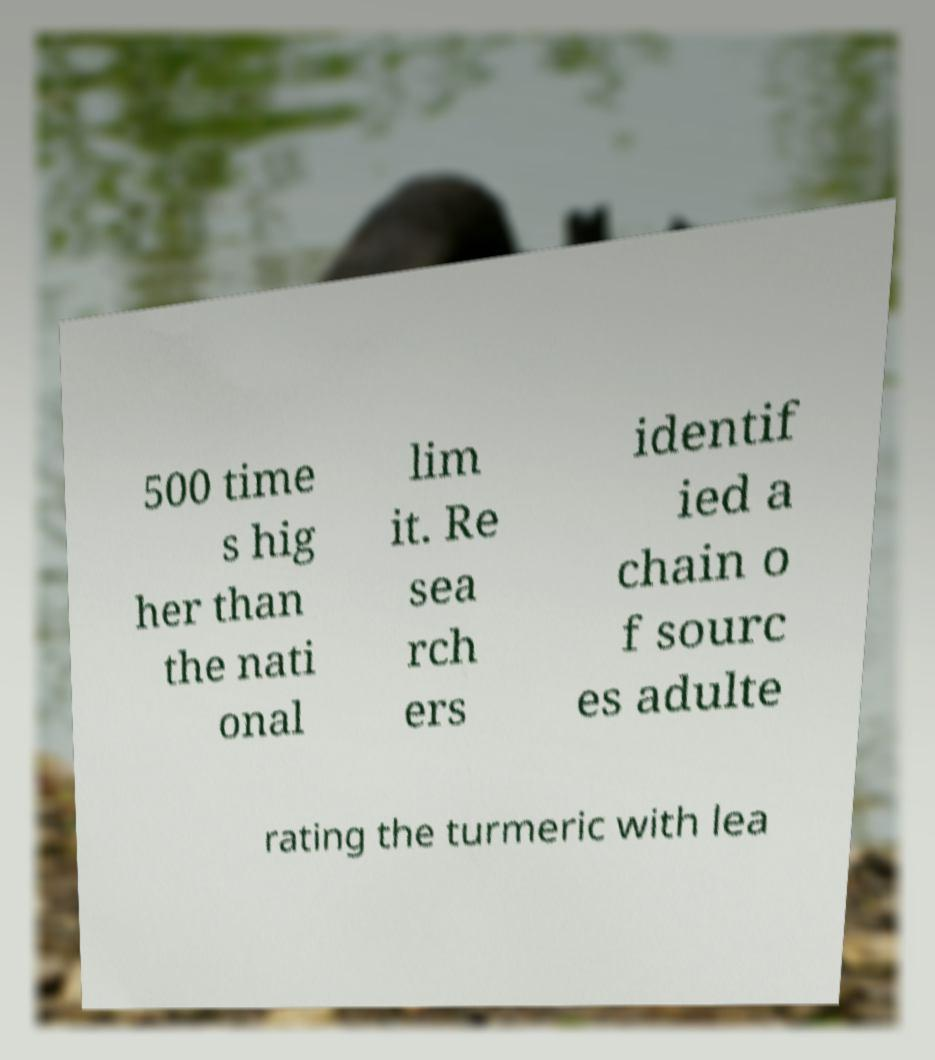I need the written content from this picture converted into text. Can you do that? 500 time s hig her than the nati onal lim it. Re sea rch ers identif ied a chain o f sourc es adulte rating the turmeric with lea 